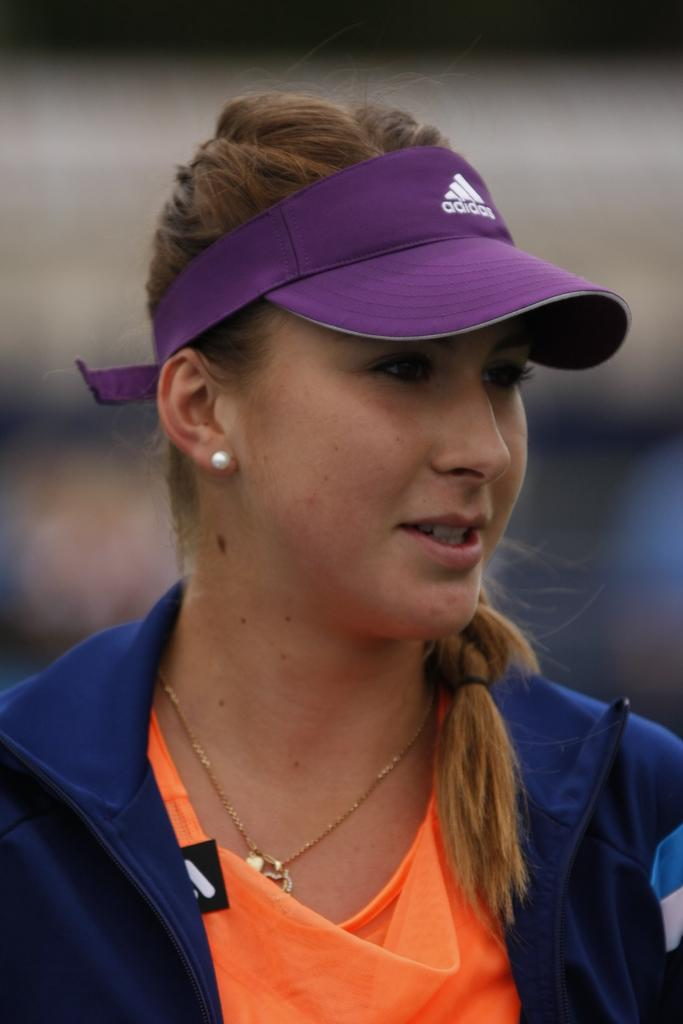Who is the main subject in the image? There is a woman in the image. What is the woman wearing? The woman is wearing an orange and blue colored dress and a purple colored cap. Can you describe the background of the image? The background of the image is blurry. What type of feeling does the woman's knee express in the image? There is no indication of the woman's knee or any feelings expressed by it in the image. 